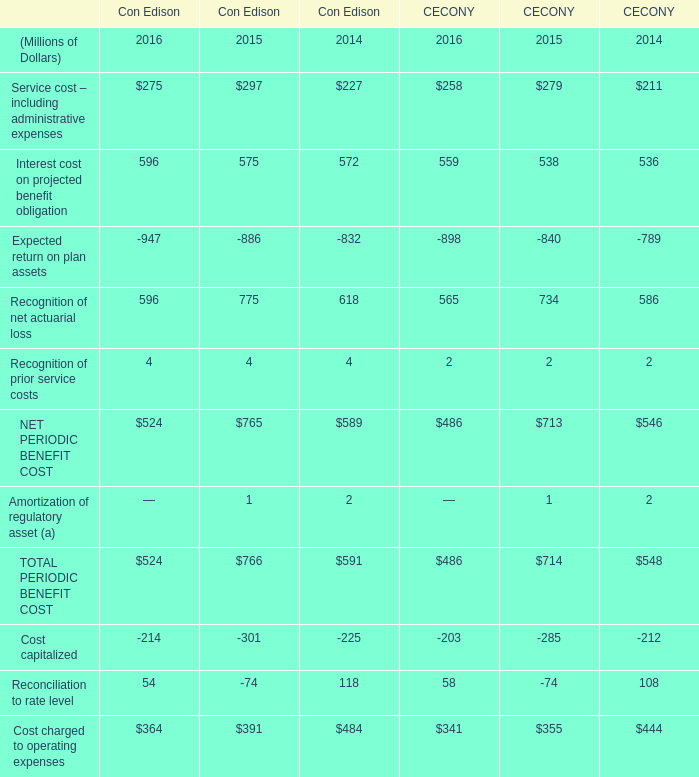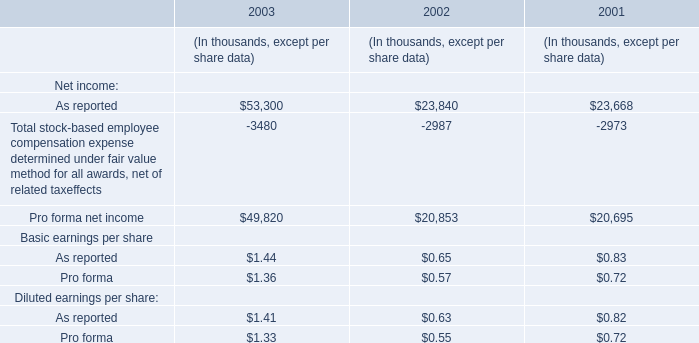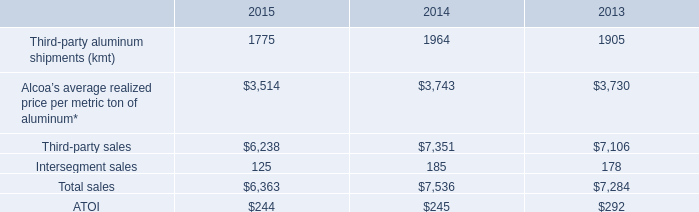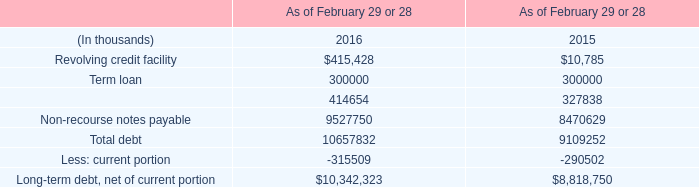What's the growth rate of Interest cost on projected benefit obligation for Con Edison in 2016? 
Computations: ((596 - 575) / 575)
Answer: 0.03652. 